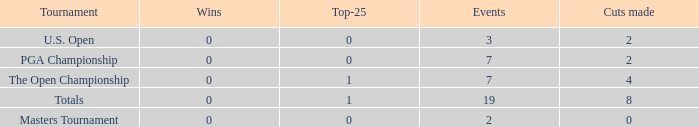What is the Wins of the Top-25 of 1 and 7 Events? 0.0. 